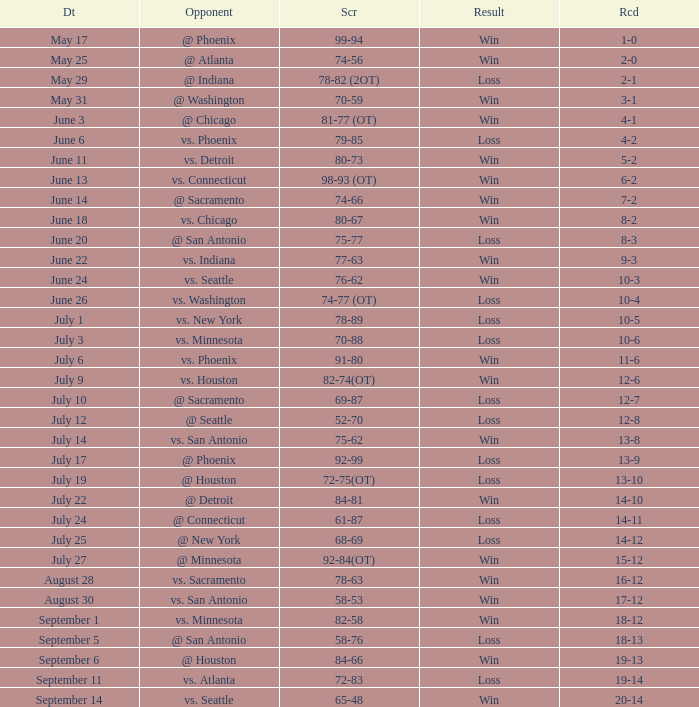What is the Score of the game @ San Antonio on June 20? 75-77. 